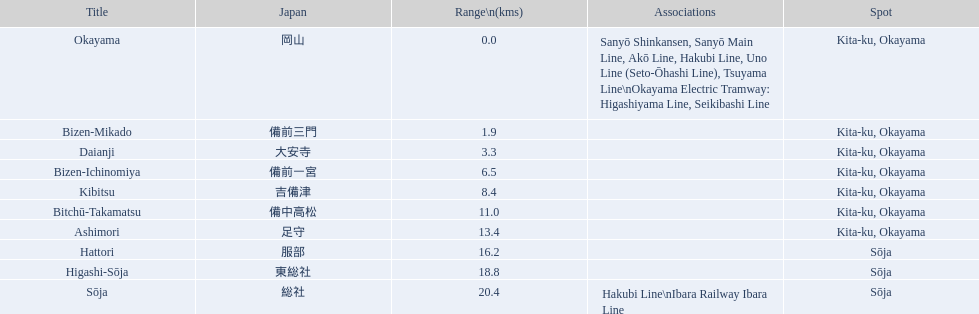What are all the stations on the kibi line? Okayama, Bizen-Mikado, Daianji, Bizen-Ichinomiya, Kibitsu, Bitchū-Takamatsu, Ashimori, Hattori, Higashi-Sōja, Sōja. What are the distances of these stations from the start of the line? 0.0, 1.9, 3.3, 6.5, 8.4, 11.0, 13.4, 16.2, 18.8, 20.4. Of these, which is larger than 1 km? 1.9, 3.3, 6.5, 8.4, 11.0, 13.4, 16.2, 18.8, 20.4. Of these, which is smaller than 2 km? 1.9. Which station is this distance from the start of the line? Bizen-Mikado. 